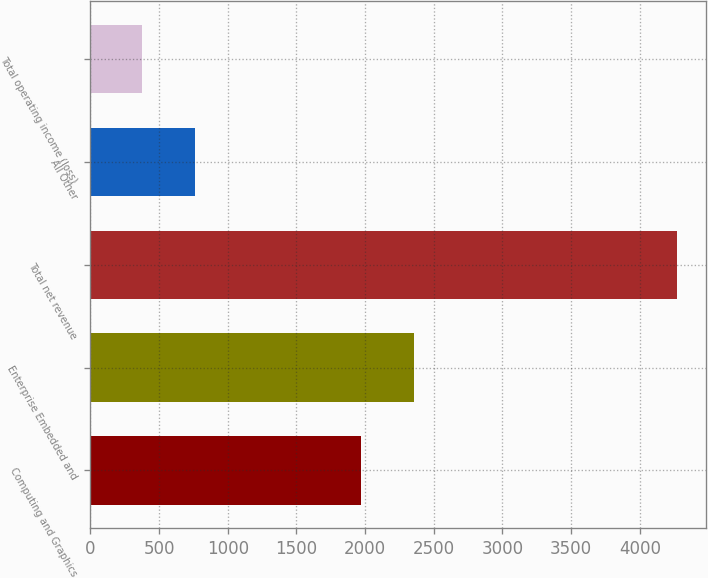<chart> <loc_0><loc_0><loc_500><loc_500><bar_chart><fcel>Computing and Graphics<fcel>Enterprise Embedded and<fcel>Total net revenue<fcel>All Other<fcel>Total operating income (loss)<nl><fcel>1967<fcel>2357<fcel>4272<fcel>762<fcel>372<nl></chart> 